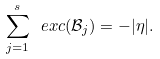Convert formula to latex. <formula><loc_0><loc_0><loc_500><loc_500>\sum _ { j = 1 } ^ { s } \ e x c ( \mathcal { B } _ { j } ) = - | \eta | .</formula> 